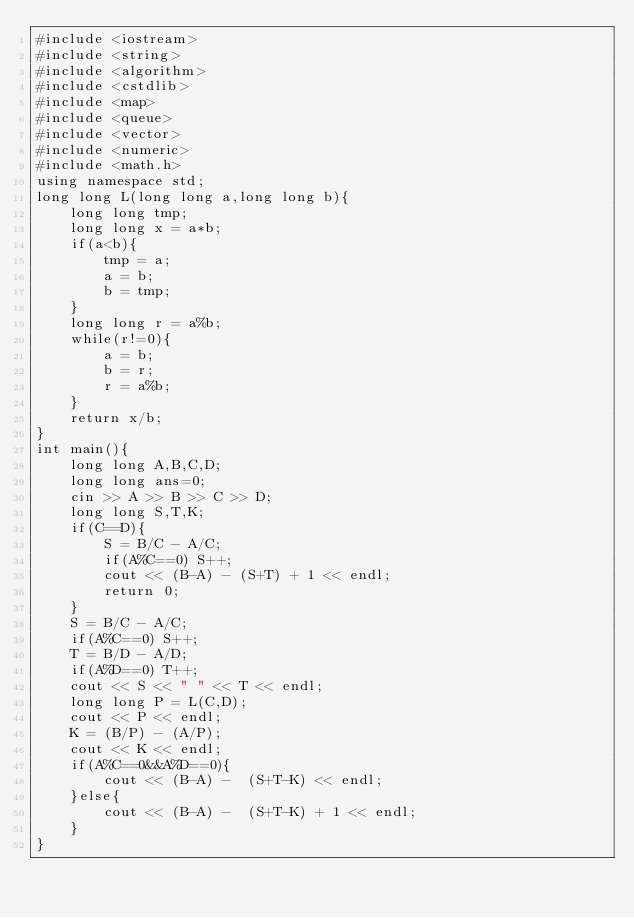<code> <loc_0><loc_0><loc_500><loc_500><_C++_>#include <iostream>
#include <string>
#include <algorithm> 
#include <cstdlib>
#include <map>
#include <queue>
#include <vector>
#include <numeric>
#include <math.h>
using namespace std;
long long L(long long a,long long b){
    long long tmp;
    long long x = a*b;
    if(a<b){
        tmp = a;
        a = b;
        b = tmp;
    }
    long long r = a%b;
    while(r!=0){
        a = b;
        b = r;
        r = a%b; 
    }
    return x/b;
}
int main(){
    long long A,B,C,D;
    long long ans=0;
    cin >> A >> B >> C >> D;
    long long S,T,K;
    if(C==D){
        S = B/C - A/C;
        if(A%C==0) S++;
        cout << (B-A) - (S+T) + 1 << endl;
        return 0;
    }
    S = B/C - A/C;
    if(A%C==0) S++;
    T = B/D - A/D;
    if(A%D==0) T++;
    cout << S << " " << T << endl;
    long long P = L(C,D); 
    cout << P << endl;
    K = (B/P) - (A/P);
    cout << K << endl;
    if(A%C==0&&A%D==0){
        cout << (B-A) -  (S+T-K) << endl;
    }else{
        cout << (B-A) -  (S+T-K) + 1 << endl;
    }
}</code> 